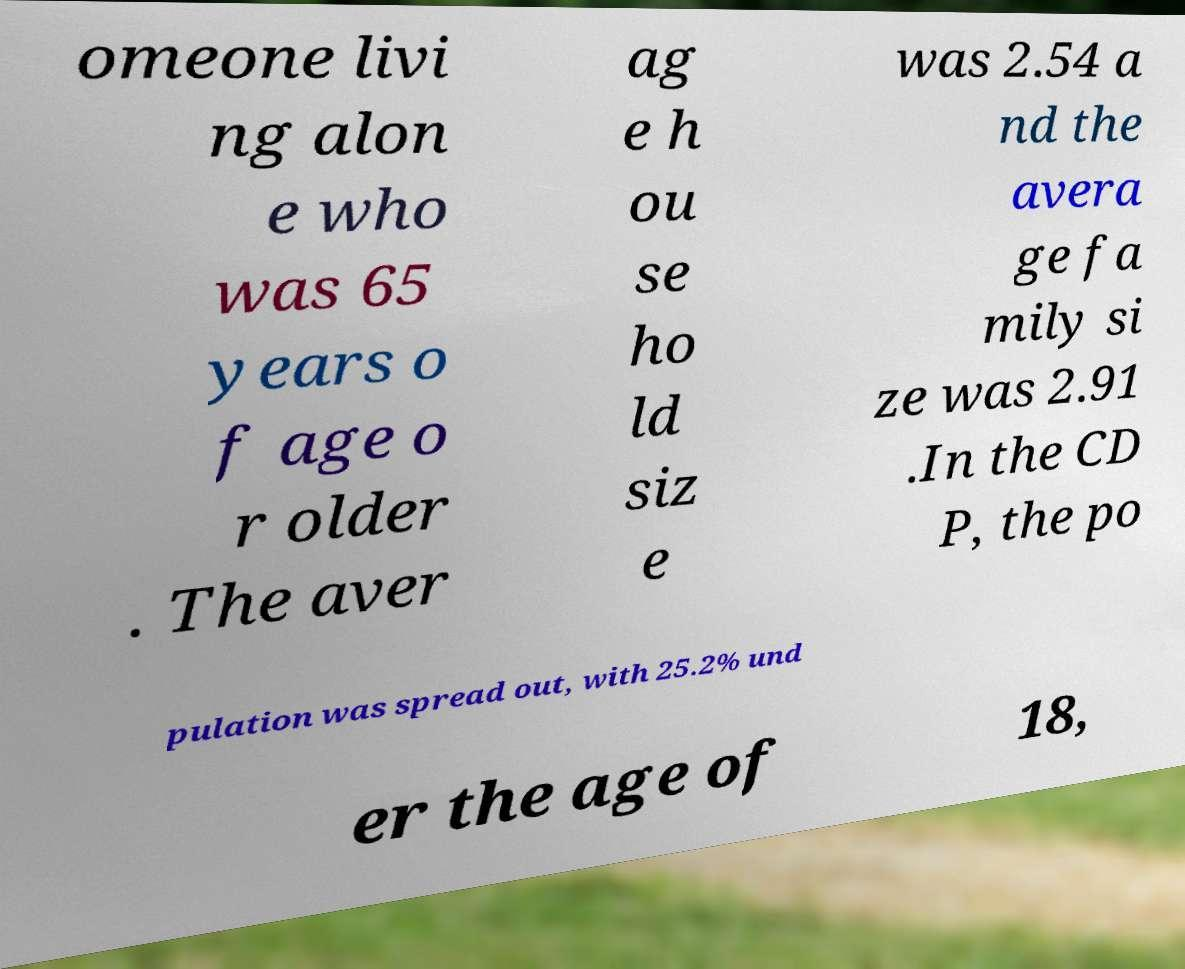Please identify and transcribe the text found in this image. omeone livi ng alon e who was 65 years o f age o r older . The aver ag e h ou se ho ld siz e was 2.54 a nd the avera ge fa mily si ze was 2.91 .In the CD P, the po pulation was spread out, with 25.2% und er the age of 18, 